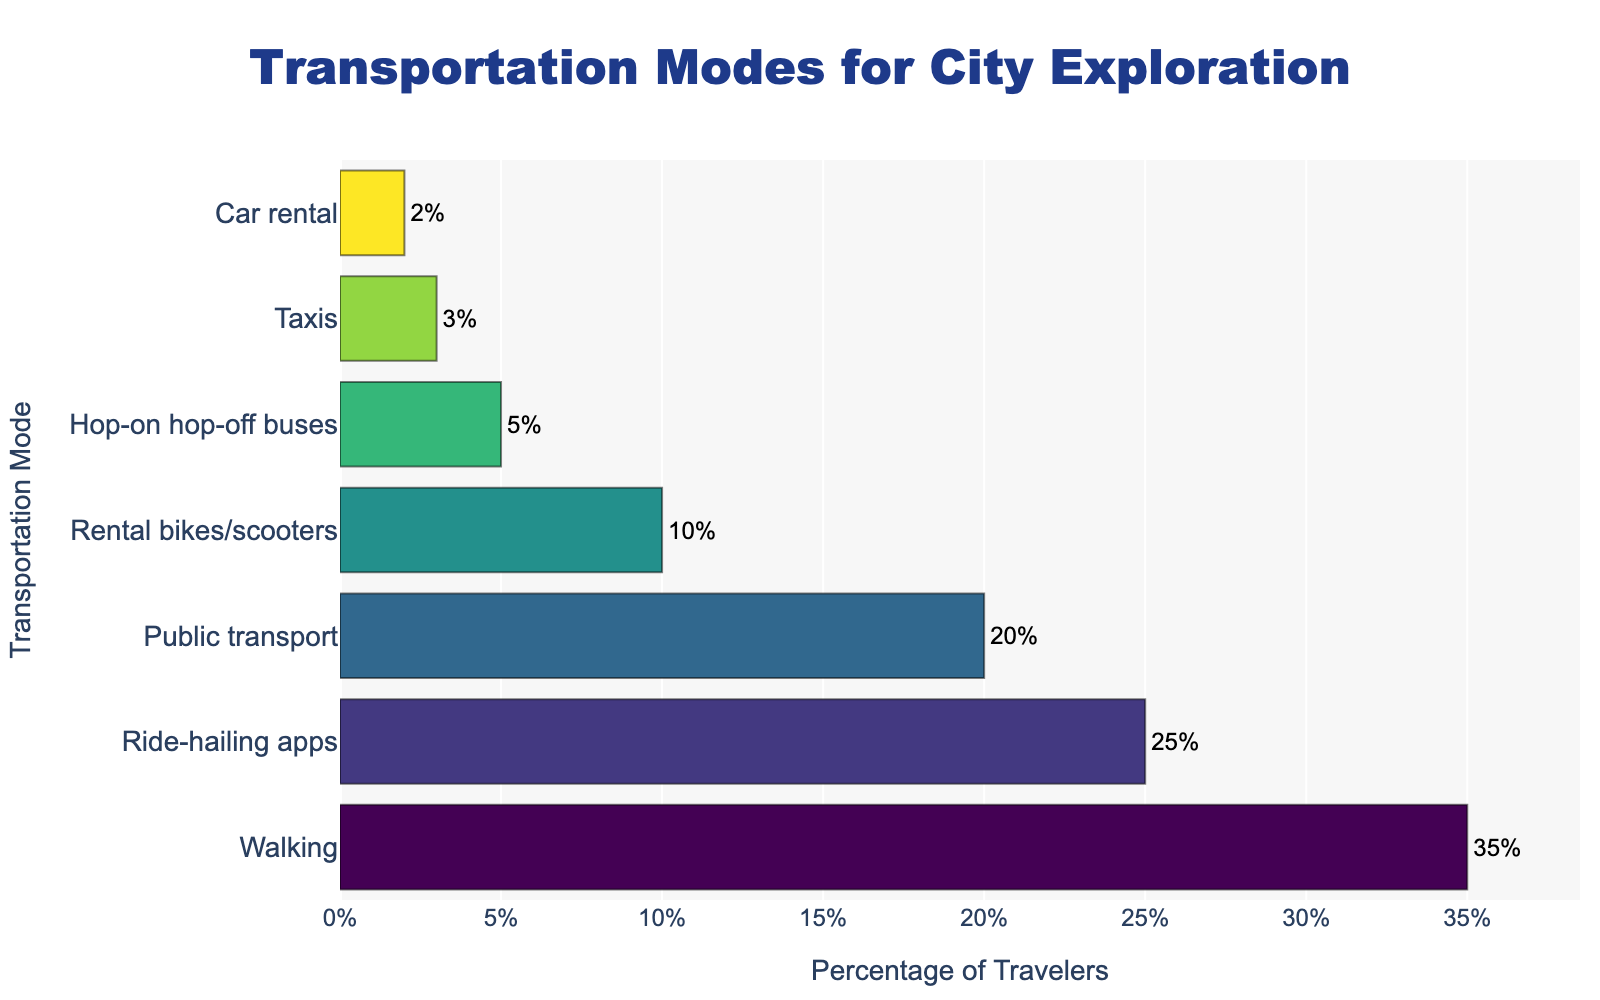What is the most commonly used transportation mode for city exploration? The figure shows different transportation modes with their respective percentages. The highest percentage bar represents the most commonly used mode.
Answer: Walking Which transportation mode is used more: ride-hailing apps or public transport? To answer this, compare the heights of the bars representing ride-hailing apps and public transport. Ride-hailing apps have a higher bar.
Answer: Ride-hailing apps What is the total percentage of travelers using either rental bikes/scooters or hop-on hop-off buses? Add the percentages of rental bikes/scooters (10%) and hop-on hop-off buses (5%). The total is 10 + 5 = 15%.
Answer: 15% How many times more travelers use walking compared to car rental? Divide the percentage of travelers using walking (35%) by the percentage using car rental (2%). 35 / 2 = 17.5.
Answer: 17.5 times Which transportation mode has a lower usage: taxis or car rental? Compare the heights of the bars for taxis and car rental. Taxis have a higher percentage than car rental, hence car rental is lower.
Answer: Car rental What is the difference in percentage between travelers using ride-hailing apps and those using public transport? Subtract the percentage of public transport (20%) from the percentage of ride-hailing apps (25%). The difference is 25 - 20 = 5%.
Answer: 5% What are the two least commonly used transportation modes? From the figure, identify the two bars with the smallest heights. These correspond to car rental (2%) and taxis (3%).
Answer: Car rental and taxis How much higher is the percentage of travelers who prefer walking compared to those who use rental bikes/scooters? Subtract the percentage of rental bikes/scooters (10%) from the percentage of walking (35%). The difference is 35 - 10 = 25%.
Answer: 25% How do the visual attributes (like bar lengths and colors) indicate the popularity of different transportation modes? Longer bars represent higher percentages, showing greater popularity. The colors are also more intense for higher percentages, with walking having the longest bar and most intense color.
Answer: Longer bars and intense colors indicate higher popularity 